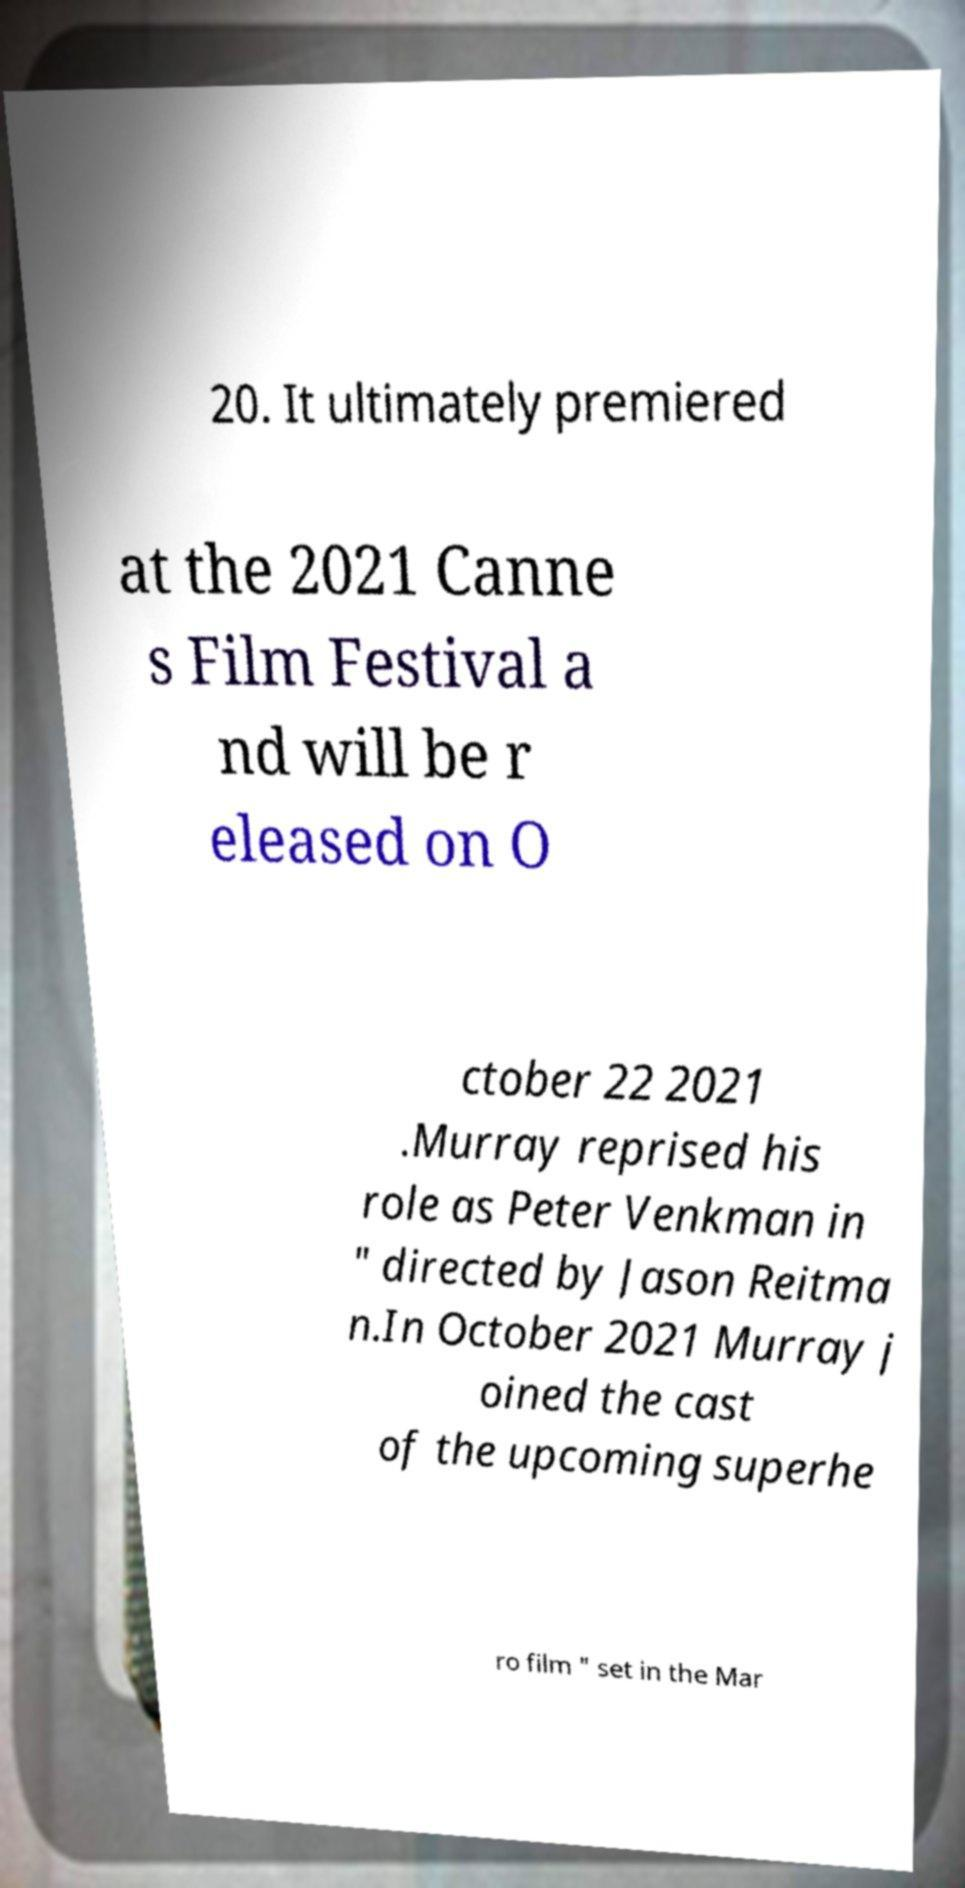Can you read and provide the text displayed in the image?This photo seems to have some interesting text. Can you extract and type it out for me? 20. It ultimately premiered at the 2021 Canne s Film Festival a nd will be r eleased on O ctober 22 2021 .Murray reprised his role as Peter Venkman in " directed by Jason Reitma n.In October 2021 Murray j oined the cast of the upcoming superhe ro film " set in the Mar 